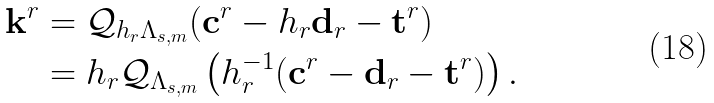<formula> <loc_0><loc_0><loc_500><loc_500>\mathbf k ^ { r } & = \mathcal { Q } _ { h _ { r } \Lambda _ { s , m } } ( \mathbf c ^ { r } - h _ { r } \mathbf d _ { r } - \mathbf t ^ { r } ) \\ & = h _ { r } \mathcal { Q } _ { \Lambda _ { s , m } } \left ( h _ { r } ^ { - 1 } ( \mathbf c ^ { r } - \mathbf d _ { r } - \mathbf t ^ { r } ) \right ) .</formula> 